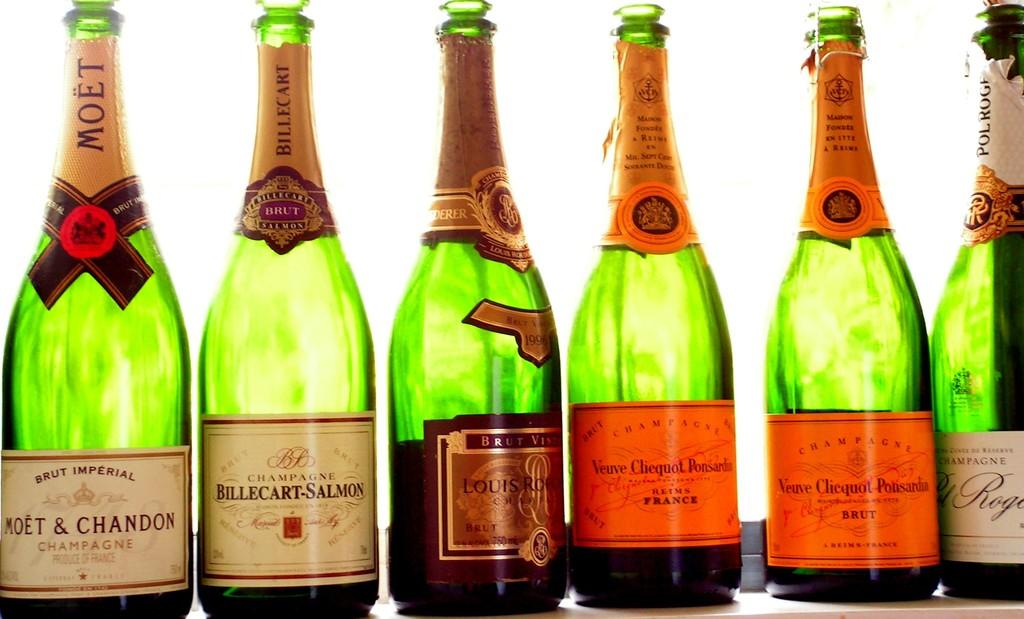What type of drink is the bottle on the far left?
Provide a succinct answer. Champagne. What brand is the beverage on the far left?
Offer a terse response. Moet & chandon. 